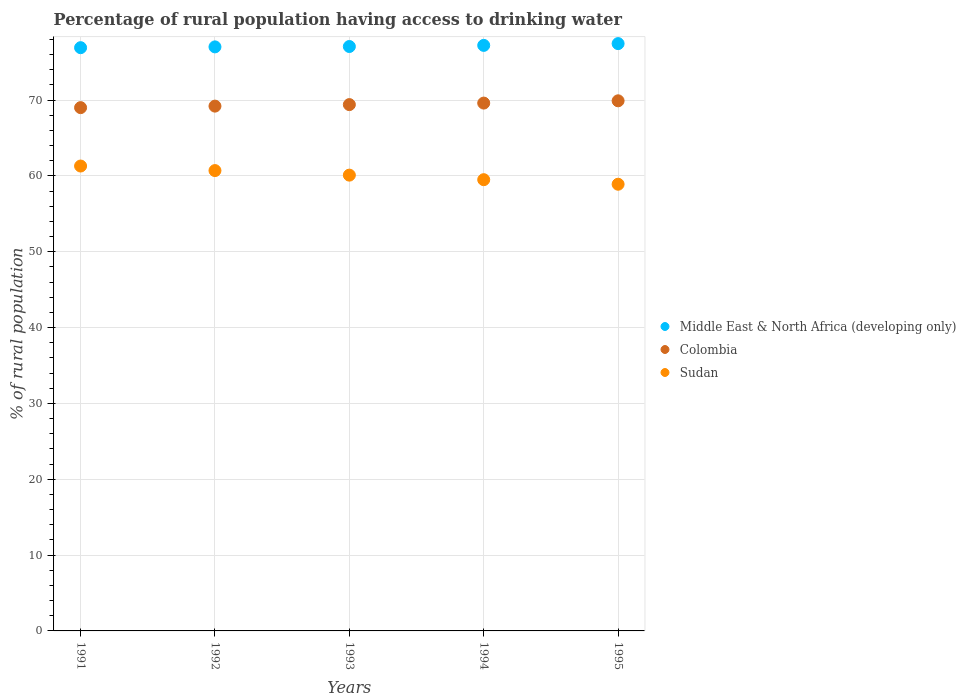How many different coloured dotlines are there?
Provide a short and direct response. 3. What is the percentage of rural population having access to drinking water in Colombia in 1995?
Provide a short and direct response. 69.9. Across all years, what is the maximum percentage of rural population having access to drinking water in Colombia?
Your response must be concise. 69.9. Across all years, what is the minimum percentage of rural population having access to drinking water in Sudan?
Make the answer very short. 58.9. In which year was the percentage of rural population having access to drinking water in Middle East & North Africa (developing only) minimum?
Keep it short and to the point. 1991. What is the total percentage of rural population having access to drinking water in Sudan in the graph?
Give a very brief answer. 300.5. What is the difference between the percentage of rural population having access to drinking water in Colombia in 1992 and that in 1995?
Provide a succinct answer. -0.7. What is the difference between the percentage of rural population having access to drinking water in Middle East & North Africa (developing only) in 1993 and the percentage of rural population having access to drinking water in Sudan in 1992?
Offer a terse response. 16.36. What is the average percentage of rural population having access to drinking water in Sudan per year?
Your answer should be very brief. 60.1. In the year 1991, what is the difference between the percentage of rural population having access to drinking water in Middle East & North Africa (developing only) and percentage of rural population having access to drinking water in Sudan?
Your response must be concise. 15.61. What is the ratio of the percentage of rural population having access to drinking water in Sudan in 1992 to that in 1995?
Keep it short and to the point. 1.03. What is the difference between the highest and the second highest percentage of rural population having access to drinking water in Sudan?
Offer a terse response. 0.6. What is the difference between the highest and the lowest percentage of rural population having access to drinking water in Sudan?
Ensure brevity in your answer.  2.4. Is it the case that in every year, the sum of the percentage of rural population having access to drinking water in Sudan and percentage of rural population having access to drinking water in Colombia  is greater than the percentage of rural population having access to drinking water in Middle East & North Africa (developing only)?
Your answer should be compact. Yes. Is the percentage of rural population having access to drinking water in Middle East & North Africa (developing only) strictly less than the percentage of rural population having access to drinking water in Colombia over the years?
Offer a terse response. No. How many years are there in the graph?
Your response must be concise. 5. Are the values on the major ticks of Y-axis written in scientific E-notation?
Your answer should be very brief. No. Does the graph contain grids?
Your answer should be very brief. Yes. How many legend labels are there?
Make the answer very short. 3. How are the legend labels stacked?
Keep it short and to the point. Vertical. What is the title of the graph?
Provide a short and direct response. Percentage of rural population having access to drinking water. What is the label or title of the X-axis?
Your response must be concise. Years. What is the label or title of the Y-axis?
Keep it short and to the point. % of rural population. What is the % of rural population in Middle East & North Africa (developing only) in 1991?
Ensure brevity in your answer.  76.91. What is the % of rural population in Sudan in 1991?
Ensure brevity in your answer.  61.3. What is the % of rural population in Middle East & North Africa (developing only) in 1992?
Keep it short and to the point. 77.01. What is the % of rural population in Colombia in 1992?
Offer a terse response. 69.2. What is the % of rural population of Sudan in 1992?
Offer a very short reply. 60.7. What is the % of rural population of Middle East & North Africa (developing only) in 1993?
Provide a succinct answer. 77.06. What is the % of rural population of Colombia in 1993?
Offer a terse response. 69.4. What is the % of rural population of Sudan in 1993?
Keep it short and to the point. 60.1. What is the % of rural population of Middle East & North Africa (developing only) in 1994?
Offer a very short reply. 77.21. What is the % of rural population of Colombia in 1994?
Your answer should be very brief. 69.6. What is the % of rural population in Sudan in 1994?
Offer a very short reply. 59.5. What is the % of rural population in Middle East & North Africa (developing only) in 1995?
Offer a terse response. 77.44. What is the % of rural population of Colombia in 1995?
Give a very brief answer. 69.9. What is the % of rural population in Sudan in 1995?
Give a very brief answer. 58.9. Across all years, what is the maximum % of rural population in Middle East & North Africa (developing only)?
Keep it short and to the point. 77.44. Across all years, what is the maximum % of rural population in Colombia?
Provide a short and direct response. 69.9. Across all years, what is the maximum % of rural population in Sudan?
Your answer should be compact. 61.3. Across all years, what is the minimum % of rural population of Middle East & North Africa (developing only)?
Give a very brief answer. 76.91. Across all years, what is the minimum % of rural population in Colombia?
Your answer should be very brief. 69. Across all years, what is the minimum % of rural population in Sudan?
Provide a succinct answer. 58.9. What is the total % of rural population in Middle East & North Africa (developing only) in the graph?
Offer a terse response. 385.63. What is the total % of rural population of Colombia in the graph?
Provide a short and direct response. 347.1. What is the total % of rural population of Sudan in the graph?
Your answer should be compact. 300.5. What is the difference between the % of rural population in Middle East & North Africa (developing only) in 1991 and that in 1992?
Make the answer very short. -0.11. What is the difference between the % of rural population of Colombia in 1991 and that in 1992?
Your answer should be compact. -0.2. What is the difference between the % of rural population of Sudan in 1991 and that in 1992?
Ensure brevity in your answer.  0.6. What is the difference between the % of rural population in Middle East & North Africa (developing only) in 1991 and that in 1993?
Offer a very short reply. -0.15. What is the difference between the % of rural population of Colombia in 1991 and that in 1993?
Offer a terse response. -0.4. What is the difference between the % of rural population in Sudan in 1991 and that in 1993?
Your answer should be compact. 1.2. What is the difference between the % of rural population in Middle East & North Africa (developing only) in 1991 and that in 1994?
Provide a succinct answer. -0.3. What is the difference between the % of rural population in Middle East & North Africa (developing only) in 1991 and that in 1995?
Provide a succinct answer. -0.54. What is the difference between the % of rural population of Sudan in 1991 and that in 1995?
Make the answer very short. 2.4. What is the difference between the % of rural population of Middle East & North Africa (developing only) in 1992 and that in 1993?
Your answer should be compact. -0.05. What is the difference between the % of rural population in Colombia in 1992 and that in 1993?
Your answer should be very brief. -0.2. What is the difference between the % of rural population in Sudan in 1992 and that in 1993?
Provide a succinct answer. 0.6. What is the difference between the % of rural population in Middle East & North Africa (developing only) in 1992 and that in 1994?
Your answer should be compact. -0.2. What is the difference between the % of rural population of Middle East & North Africa (developing only) in 1992 and that in 1995?
Provide a short and direct response. -0.43. What is the difference between the % of rural population of Colombia in 1992 and that in 1995?
Your response must be concise. -0.7. What is the difference between the % of rural population in Middle East & North Africa (developing only) in 1993 and that in 1994?
Offer a terse response. -0.15. What is the difference between the % of rural population of Colombia in 1993 and that in 1994?
Your answer should be very brief. -0.2. What is the difference between the % of rural population in Middle East & North Africa (developing only) in 1993 and that in 1995?
Offer a very short reply. -0.38. What is the difference between the % of rural population of Middle East & North Africa (developing only) in 1994 and that in 1995?
Offer a terse response. -0.23. What is the difference between the % of rural population in Middle East & North Africa (developing only) in 1991 and the % of rural population in Colombia in 1992?
Offer a very short reply. 7.71. What is the difference between the % of rural population of Middle East & North Africa (developing only) in 1991 and the % of rural population of Sudan in 1992?
Provide a succinct answer. 16.21. What is the difference between the % of rural population of Colombia in 1991 and the % of rural population of Sudan in 1992?
Provide a succinct answer. 8.3. What is the difference between the % of rural population in Middle East & North Africa (developing only) in 1991 and the % of rural population in Colombia in 1993?
Give a very brief answer. 7.51. What is the difference between the % of rural population of Middle East & North Africa (developing only) in 1991 and the % of rural population of Sudan in 1993?
Provide a short and direct response. 16.81. What is the difference between the % of rural population of Colombia in 1991 and the % of rural population of Sudan in 1993?
Your response must be concise. 8.9. What is the difference between the % of rural population in Middle East & North Africa (developing only) in 1991 and the % of rural population in Colombia in 1994?
Give a very brief answer. 7.31. What is the difference between the % of rural population in Middle East & North Africa (developing only) in 1991 and the % of rural population in Sudan in 1994?
Ensure brevity in your answer.  17.41. What is the difference between the % of rural population of Colombia in 1991 and the % of rural population of Sudan in 1994?
Make the answer very short. 9.5. What is the difference between the % of rural population in Middle East & North Africa (developing only) in 1991 and the % of rural population in Colombia in 1995?
Your response must be concise. 7.01. What is the difference between the % of rural population of Middle East & North Africa (developing only) in 1991 and the % of rural population of Sudan in 1995?
Give a very brief answer. 18.01. What is the difference between the % of rural population of Colombia in 1991 and the % of rural population of Sudan in 1995?
Ensure brevity in your answer.  10.1. What is the difference between the % of rural population in Middle East & North Africa (developing only) in 1992 and the % of rural population in Colombia in 1993?
Offer a terse response. 7.61. What is the difference between the % of rural population of Middle East & North Africa (developing only) in 1992 and the % of rural population of Sudan in 1993?
Offer a very short reply. 16.91. What is the difference between the % of rural population of Middle East & North Africa (developing only) in 1992 and the % of rural population of Colombia in 1994?
Offer a terse response. 7.41. What is the difference between the % of rural population of Middle East & North Africa (developing only) in 1992 and the % of rural population of Sudan in 1994?
Your answer should be very brief. 17.51. What is the difference between the % of rural population of Middle East & North Africa (developing only) in 1992 and the % of rural population of Colombia in 1995?
Give a very brief answer. 7.11. What is the difference between the % of rural population of Middle East & North Africa (developing only) in 1992 and the % of rural population of Sudan in 1995?
Your response must be concise. 18.11. What is the difference between the % of rural population in Middle East & North Africa (developing only) in 1993 and the % of rural population in Colombia in 1994?
Offer a very short reply. 7.46. What is the difference between the % of rural population of Middle East & North Africa (developing only) in 1993 and the % of rural population of Sudan in 1994?
Make the answer very short. 17.56. What is the difference between the % of rural population of Middle East & North Africa (developing only) in 1993 and the % of rural population of Colombia in 1995?
Your answer should be compact. 7.16. What is the difference between the % of rural population in Middle East & North Africa (developing only) in 1993 and the % of rural population in Sudan in 1995?
Ensure brevity in your answer.  18.16. What is the difference between the % of rural population in Colombia in 1993 and the % of rural population in Sudan in 1995?
Give a very brief answer. 10.5. What is the difference between the % of rural population of Middle East & North Africa (developing only) in 1994 and the % of rural population of Colombia in 1995?
Give a very brief answer. 7.31. What is the difference between the % of rural population of Middle East & North Africa (developing only) in 1994 and the % of rural population of Sudan in 1995?
Offer a very short reply. 18.31. What is the average % of rural population of Middle East & North Africa (developing only) per year?
Provide a short and direct response. 77.13. What is the average % of rural population in Colombia per year?
Your answer should be compact. 69.42. What is the average % of rural population in Sudan per year?
Make the answer very short. 60.1. In the year 1991, what is the difference between the % of rural population in Middle East & North Africa (developing only) and % of rural population in Colombia?
Make the answer very short. 7.91. In the year 1991, what is the difference between the % of rural population in Middle East & North Africa (developing only) and % of rural population in Sudan?
Provide a succinct answer. 15.61. In the year 1991, what is the difference between the % of rural population of Colombia and % of rural population of Sudan?
Provide a succinct answer. 7.7. In the year 1992, what is the difference between the % of rural population of Middle East & North Africa (developing only) and % of rural population of Colombia?
Your answer should be compact. 7.81. In the year 1992, what is the difference between the % of rural population in Middle East & North Africa (developing only) and % of rural population in Sudan?
Provide a succinct answer. 16.31. In the year 1992, what is the difference between the % of rural population in Colombia and % of rural population in Sudan?
Provide a short and direct response. 8.5. In the year 1993, what is the difference between the % of rural population in Middle East & North Africa (developing only) and % of rural population in Colombia?
Your answer should be very brief. 7.66. In the year 1993, what is the difference between the % of rural population of Middle East & North Africa (developing only) and % of rural population of Sudan?
Provide a short and direct response. 16.96. In the year 1994, what is the difference between the % of rural population in Middle East & North Africa (developing only) and % of rural population in Colombia?
Keep it short and to the point. 7.61. In the year 1994, what is the difference between the % of rural population in Middle East & North Africa (developing only) and % of rural population in Sudan?
Keep it short and to the point. 17.71. In the year 1994, what is the difference between the % of rural population in Colombia and % of rural population in Sudan?
Keep it short and to the point. 10.1. In the year 1995, what is the difference between the % of rural population in Middle East & North Africa (developing only) and % of rural population in Colombia?
Offer a very short reply. 7.54. In the year 1995, what is the difference between the % of rural population in Middle East & North Africa (developing only) and % of rural population in Sudan?
Your answer should be very brief. 18.54. What is the ratio of the % of rural population in Middle East & North Africa (developing only) in 1991 to that in 1992?
Give a very brief answer. 1. What is the ratio of the % of rural population of Colombia in 1991 to that in 1992?
Offer a very short reply. 1. What is the ratio of the % of rural population of Sudan in 1991 to that in 1992?
Offer a very short reply. 1.01. What is the ratio of the % of rural population in Middle East & North Africa (developing only) in 1991 to that in 1993?
Offer a terse response. 1. What is the ratio of the % of rural population in Sudan in 1991 to that in 1993?
Your response must be concise. 1.02. What is the ratio of the % of rural population in Middle East & North Africa (developing only) in 1991 to that in 1994?
Your answer should be compact. 1. What is the ratio of the % of rural population of Sudan in 1991 to that in 1994?
Give a very brief answer. 1.03. What is the ratio of the % of rural population in Colombia in 1991 to that in 1995?
Your response must be concise. 0.99. What is the ratio of the % of rural population in Sudan in 1991 to that in 1995?
Your response must be concise. 1.04. What is the ratio of the % of rural population of Middle East & North Africa (developing only) in 1992 to that in 1993?
Ensure brevity in your answer.  1. What is the ratio of the % of rural population of Middle East & North Africa (developing only) in 1992 to that in 1994?
Ensure brevity in your answer.  1. What is the ratio of the % of rural population in Sudan in 1992 to that in 1994?
Your answer should be compact. 1.02. What is the ratio of the % of rural population in Sudan in 1992 to that in 1995?
Your answer should be compact. 1.03. What is the ratio of the % of rural population of Middle East & North Africa (developing only) in 1993 to that in 1994?
Your response must be concise. 1. What is the ratio of the % of rural population in Colombia in 1993 to that in 1994?
Keep it short and to the point. 1. What is the ratio of the % of rural population of Colombia in 1993 to that in 1995?
Provide a succinct answer. 0.99. What is the ratio of the % of rural population in Sudan in 1993 to that in 1995?
Your answer should be very brief. 1.02. What is the ratio of the % of rural population in Middle East & North Africa (developing only) in 1994 to that in 1995?
Give a very brief answer. 1. What is the ratio of the % of rural population in Sudan in 1994 to that in 1995?
Offer a very short reply. 1.01. What is the difference between the highest and the second highest % of rural population of Middle East & North Africa (developing only)?
Your answer should be very brief. 0.23. What is the difference between the highest and the second highest % of rural population in Colombia?
Ensure brevity in your answer.  0.3. What is the difference between the highest and the second highest % of rural population in Sudan?
Ensure brevity in your answer.  0.6. What is the difference between the highest and the lowest % of rural population of Middle East & North Africa (developing only)?
Your answer should be very brief. 0.54. What is the difference between the highest and the lowest % of rural population in Colombia?
Give a very brief answer. 0.9. What is the difference between the highest and the lowest % of rural population of Sudan?
Offer a terse response. 2.4. 